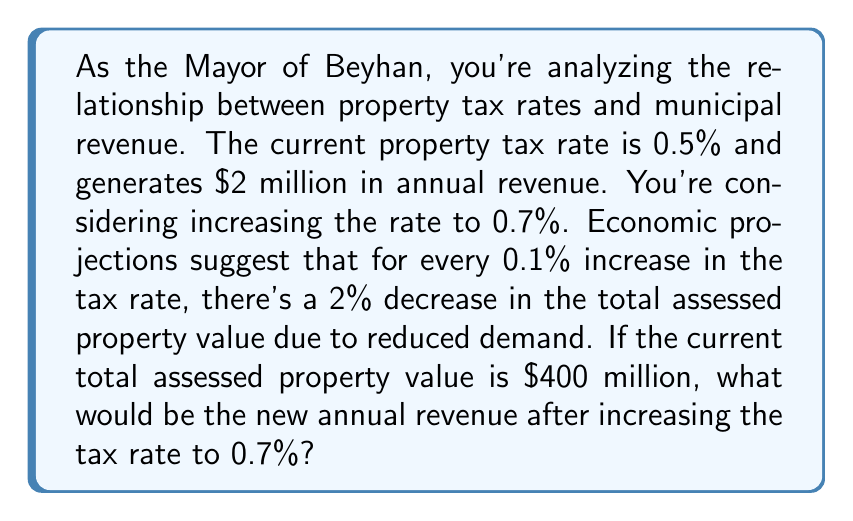Can you solve this math problem? Let's approach this step-by-step:

1) First, let's calculate the change in tax rate:
   $0.7\% - 0.5\% = 0.2\%$ increase
   This is equivalent to two 0.1% increases.

2) For each 0.1% increase, there's a 2% decrease in property value. So for a 0.2% increase, there will be a 4% decrease in property value.

3) Calculate the new total assessed property value:
   $400,000,000 \times (1 - 0.04) = $384,000,000$

4) Now, let's calculate the new revenue:
   New Revenue = New Property Value $\times$ New Tax Rate
   $$ \text{New Revenue} = $384,000,000 \times 0.007 = $2,688,000 $$

5) To verify, let's calculate the original revenue:
   $$ \text{Original Revenue} = $400,000,000 \times 0.005 = $2,000,000 $$
   This matches the given information.

Therefore, the new annual revenue after increasing the tax rate to 0.7% would be $2,688,000.
Answer: $2,688,000 